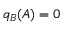Convert formula to latex. <formula><loc_0><loc_0><loc_500><loc_500>q _ { B } ( A ) = 0</formula> 